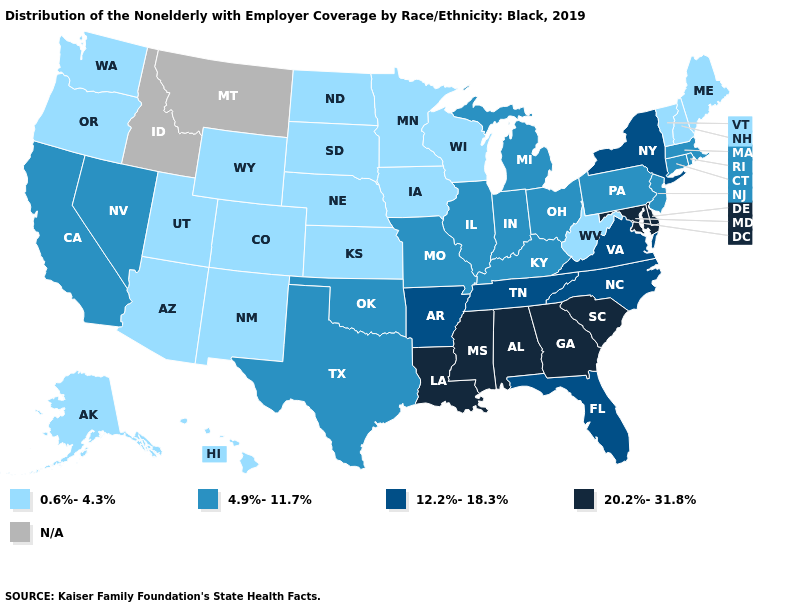Among the states that border Oregon , which have the highest value?
Give a very brief answer. California, Nevada. Does the map have missing data?
Concise answer only. Yes. What is the value of Alaska?
Give a very brief answer. 0.6%-4.3%. How many symbols are there in the legend?
Give a very brief answer. 5. Which states hav the highest value in the South?
Answer briefly. Alabama, Delaware, Georgia, Louisiana, Maryland, Mississippi, South Carolina. Among the states that border Missouri , does Nebraska have the lowest value?
Be succinct. Yes. Among the states that border Michigan , which have the highest value?
Keep it brief. Indiana, Ohio. How many symbols are there in the legend?
Be succinct. 5. Among the states that border New Jersey , which have the highest value?
Concise answer only. Delaware. Does West Virginia have the lowest value in the USA?
Give a very brief answer. Yes. What is the highest value in states that border Iowa?
Be succinct. 4.9%-11.7%. Name the states that have a value in the range 0.6%-4.3%?
Keep it brief. Alaska, Arizona, Colorado, Hawaii, Iowa, Kansas, Maine, Minnesota, Nebraska, New Hampshire, New Mexico, North Dakota, Oregon, South Dakota, Utah, Vermont, Washington, West Virginia, Wisconsin, Wyoming. Is the legend a continuous bar?
Concise answer only. No. What is the highest value in states that border Missouri?
Write a very short answer. 12.2%-18.3%. 